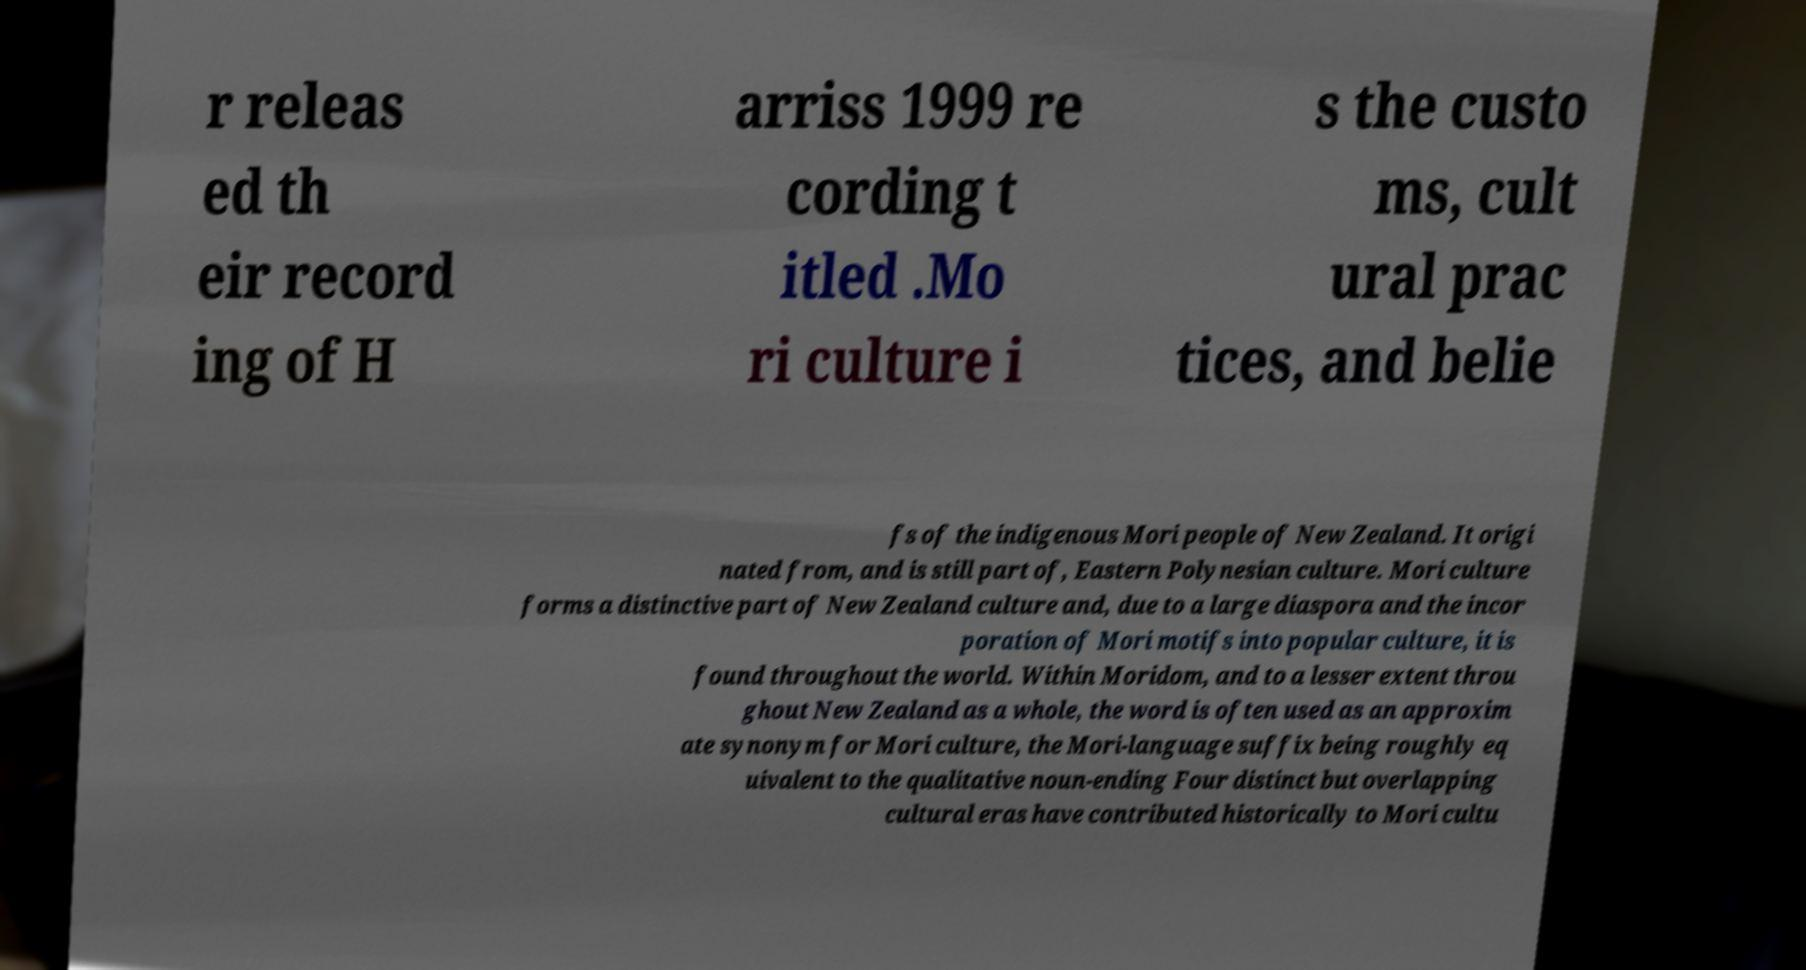There's text embedded in this image that I need extracted. Can you transcribe it verbatim? r releas ed th eir record ing of H arriss 1999 re cording t itled .Mo ri culture i s the custo ms, cult ural prac tices, and belie fs of the indigenous Mori people of New Zealand. It origi nated from, and is still part of, Eastern Polynesian culture. Mori culture forms a distinctive part of New Zealand culture and, due to a large diaspora and the incor poration of Mori motifs into popular culture, it is found throughout the world. Within Moridom, and to a lesser extent throu ghout New Zealand as a whole, the word is often used as an approxim ate synonym for Mori culture, the Mori-language suffix being roughly eq uivalent to the qualitative noun-ending Four distinct but overlapping cultural eras have contributed historically to Mori cultu 